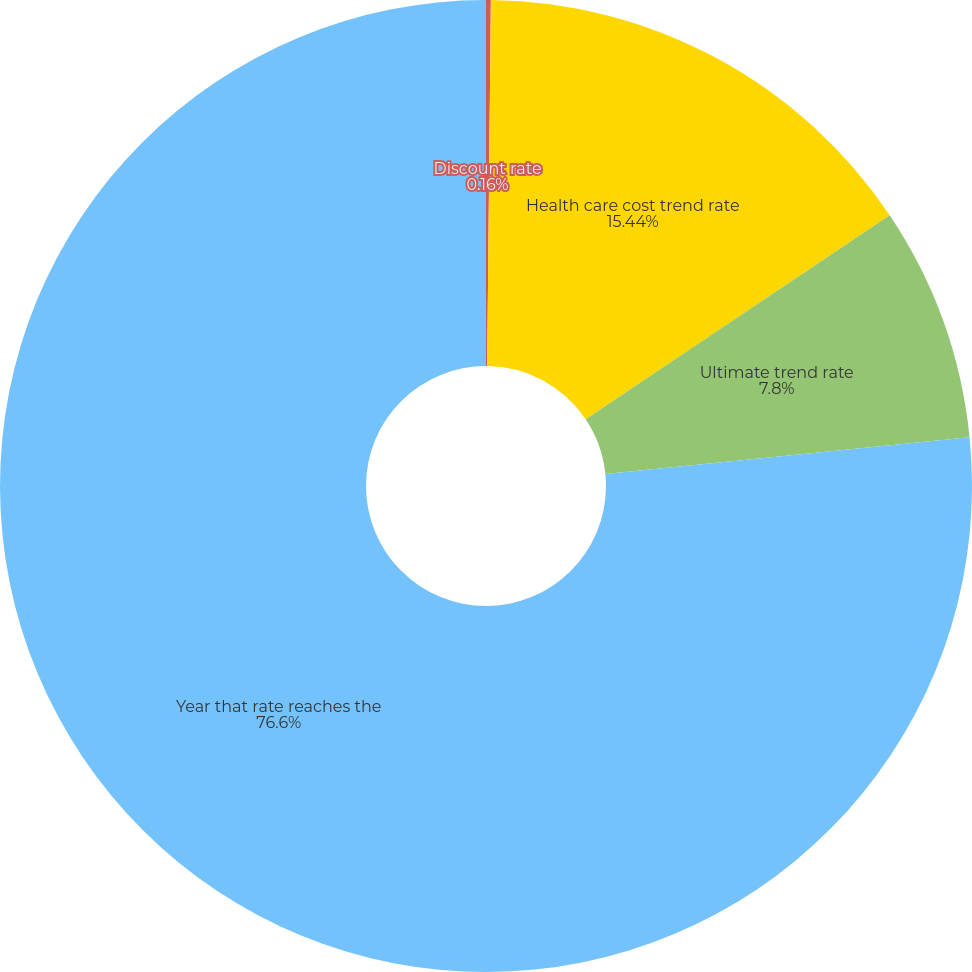Convert chart. <chart><loc_0><loc_0><loc_500><loc_500><pie_chart><fcel>Discount rate<fcel>Health care cost trend rate<fcel>Ultimate trend rate<fcel>Year that rate reaches the<nl><fcel>0.16%<fcel>15.44%<fcel>7.8%<fcel>76.6%<nl></chart> 